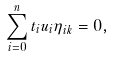Convert formula to latex. <formula><loc_0><loc_0><loc_500><loc_500>\sum _ { i = 0 } ^ { n } t _ { i } u _ { i } \eta _ { i k } = 0 ,</formula> 